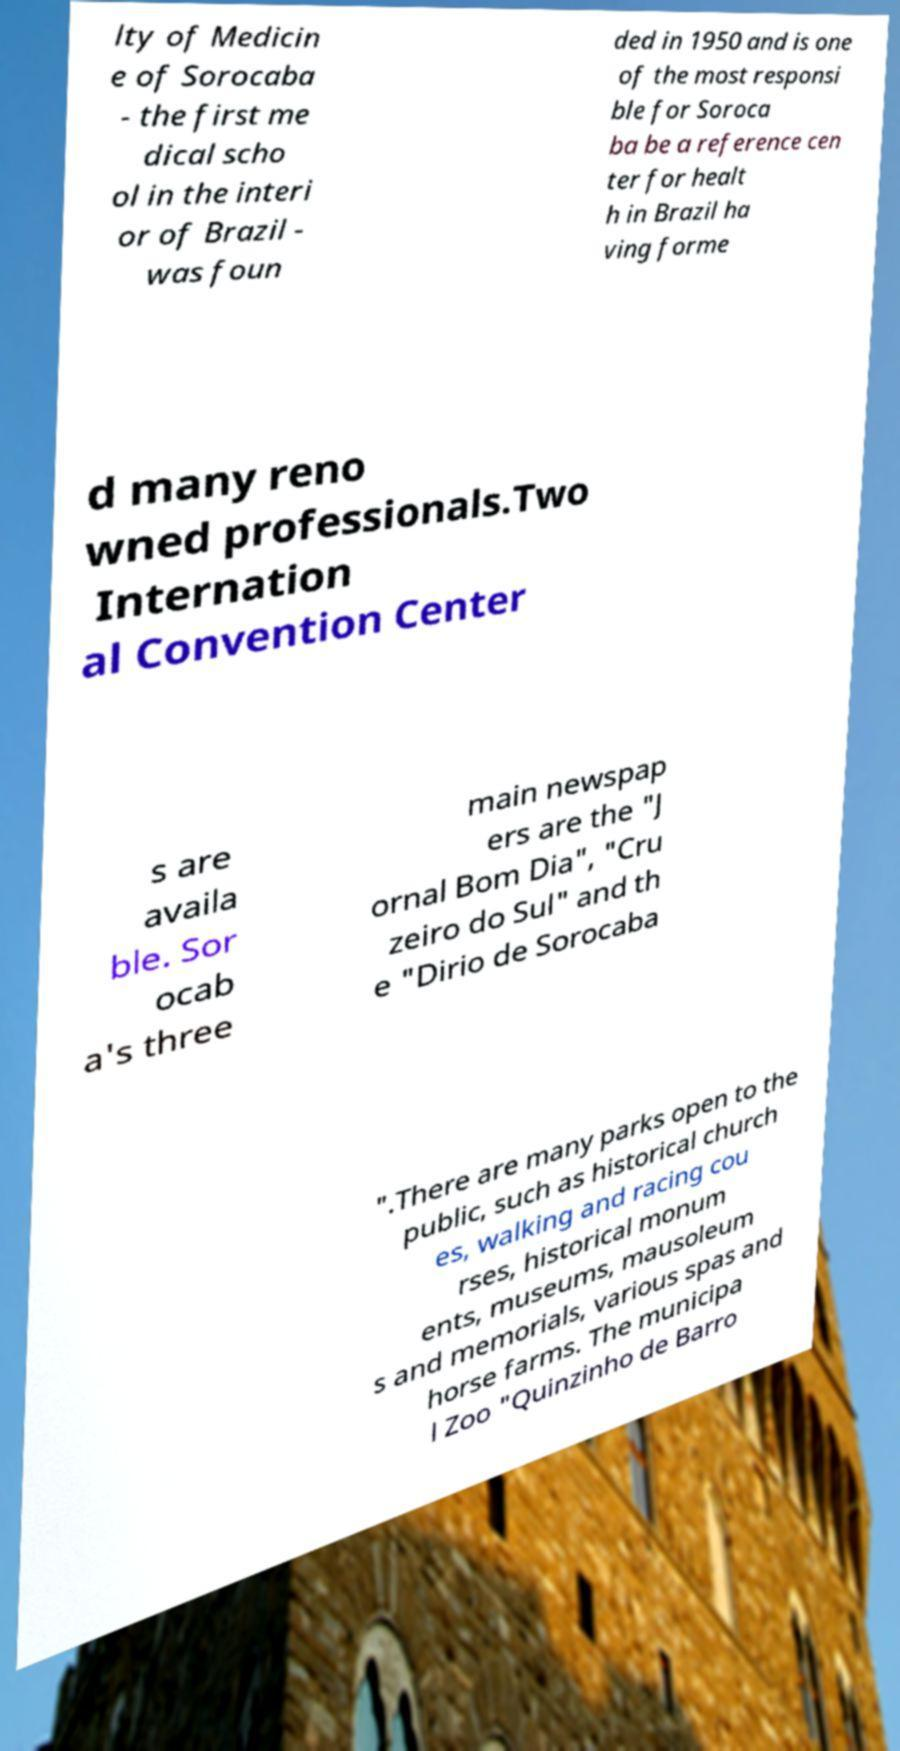Could you extract and type out the text from this image? lty of Medicin e of Sorocaba - the first me dical scho ol in the interi or of Brazil - was foun ded in 1950 and is one of the most responsi ble for Soroca ba be a reference cen ter for healt h in Brazil ha ving forme d many reno wned professionals.Two Internation al Convention Center s are availa ble. Sor ocab a's three main newspap ers are the "J ornal Bom Dia", "Cru zeiro do Sul" and th e "Dirio de Sorocaba ".There are many parks open to the public, such as historical church es, walking and racing cou rses, historical monum ents, museums, mausoleum s and memorials, various spas and horse farms. The municipa l Zoo "Quinzinho de Barro 